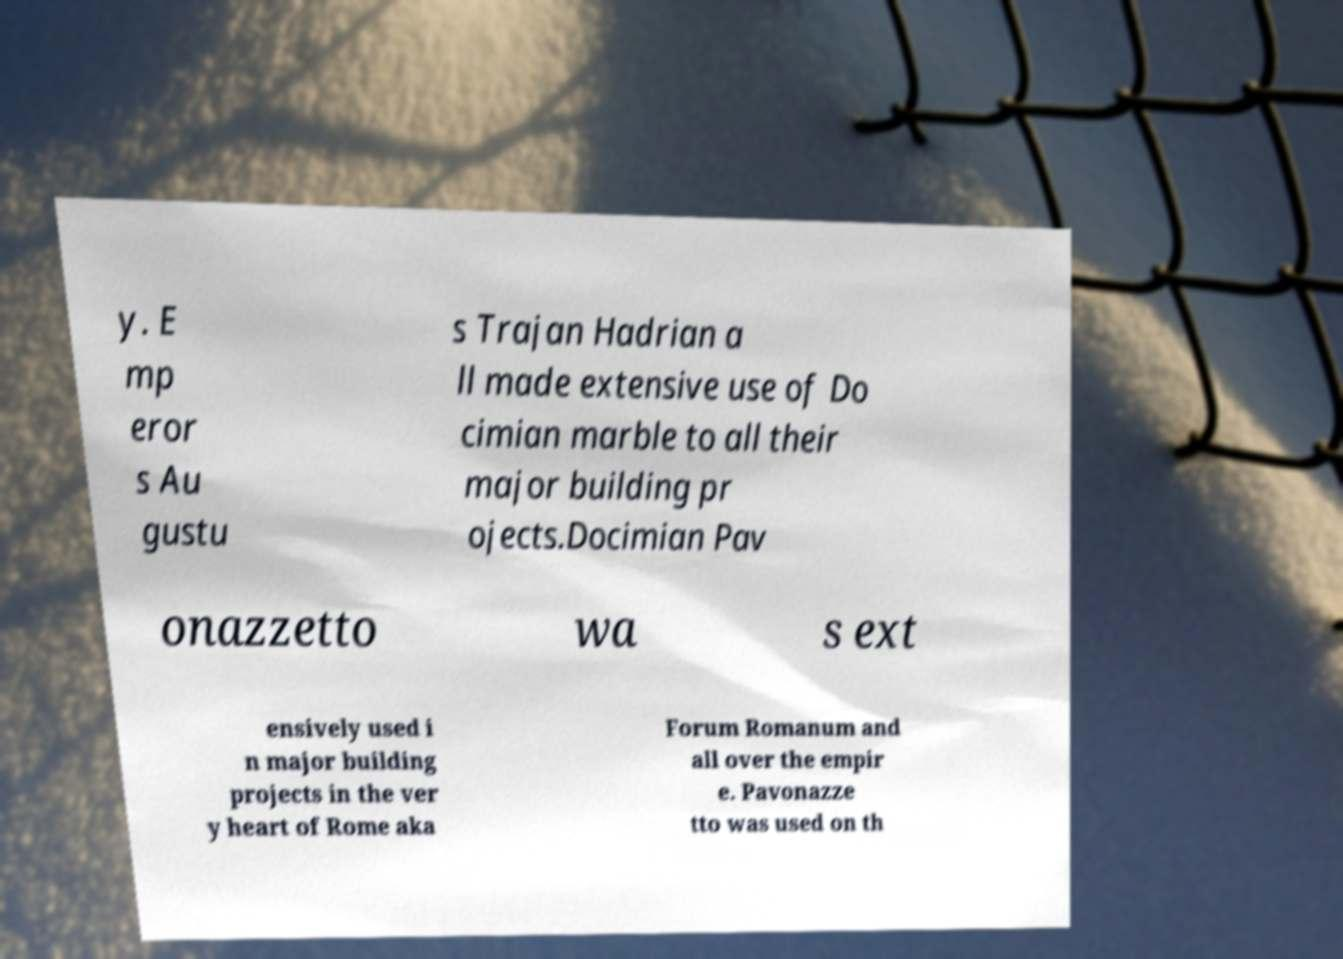There's text embedded in this image that I need extracted. Can you transcribe it verbatim? y. E mp eror s Au gustu s Trajan Hadrian a ll made extensive use of Do cimian marble to all their major building pr ojects.Docimian Pav onazzetto wa s ext ensively used i n major building projects in the ver y heart of Rome aka Forum Romanum and all over the empir e. Pavonazze tto was used on th 